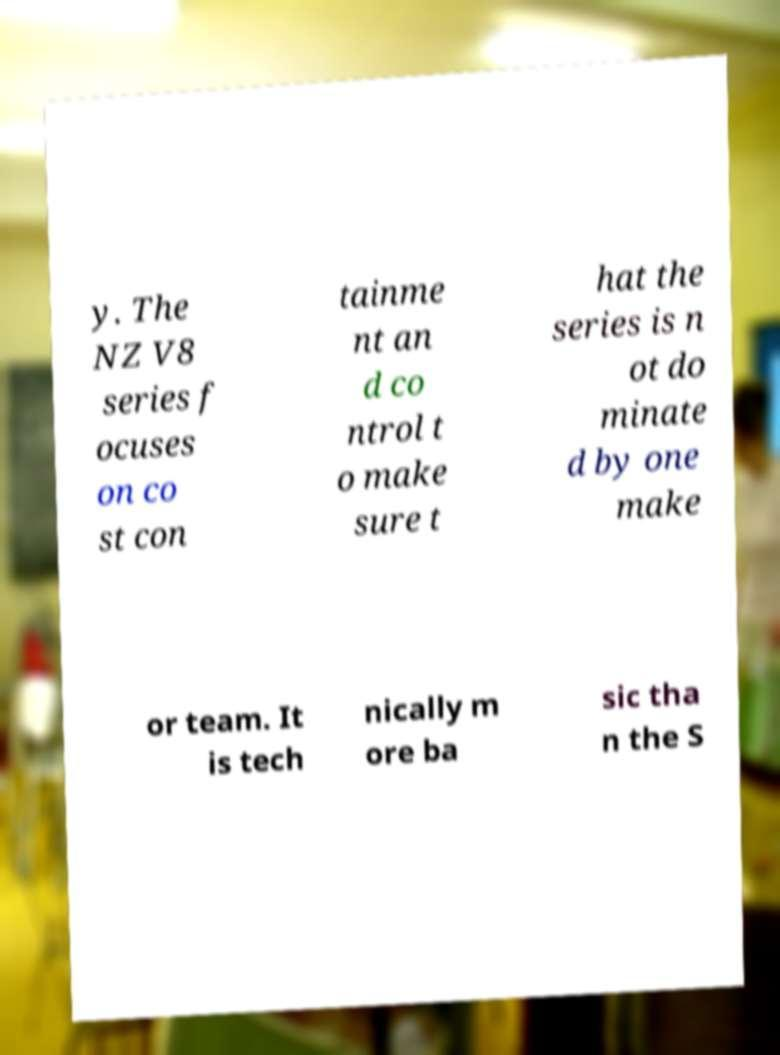Could you assist in decoding the text presented in this image and type it out clearly? y. The NZ V8 series f ocuses on co st con tainme nt an d co ntrol t o make sure t hat the series is n ot do minate d by one make or team. It is tech nically m ore ba sic tha n the S 